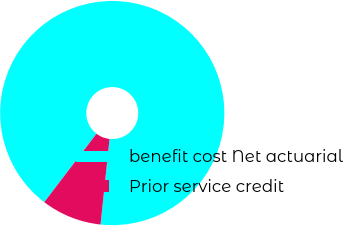<chart> <loc_0><loc_0><loc_500><loc_500><pie_chart><fcel>benefit cost Net actuarial<fcel>Prior service credit<nl><fcel>91.29%<fcel>8.71%<nl></chart> 